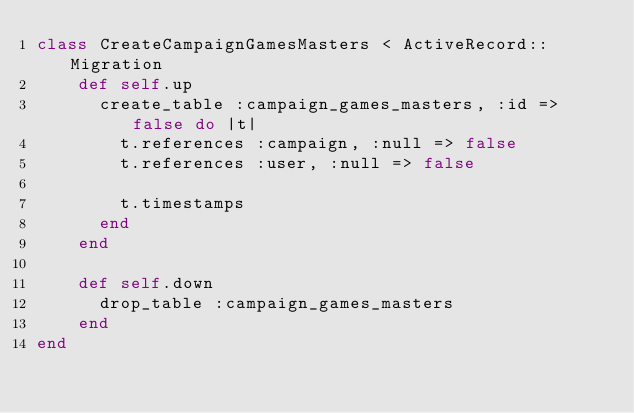Convert code to text. <code><loc_0><loc_0><loc_500><loc_500><_Ruby_>class CreateCampaignGamesMasters < ActiveRecord::Migration
    def self.up
      create_table :campaign_games_masters, :id => false do |t|
        t.references :campaign, :null => false
        t.references :user, :null => false
  
        t.timestamps
      end
    end
  
    def self.down
      drop_table :campaign_games_masters
    end
end
</code> 